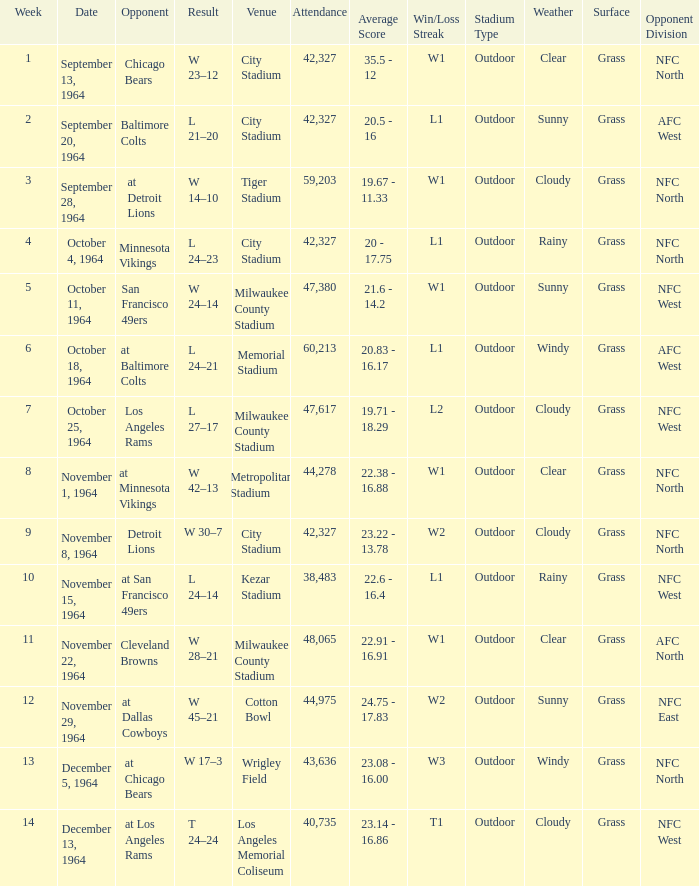What venue held that game with a result of l 24–14? Kezar Stadium. 